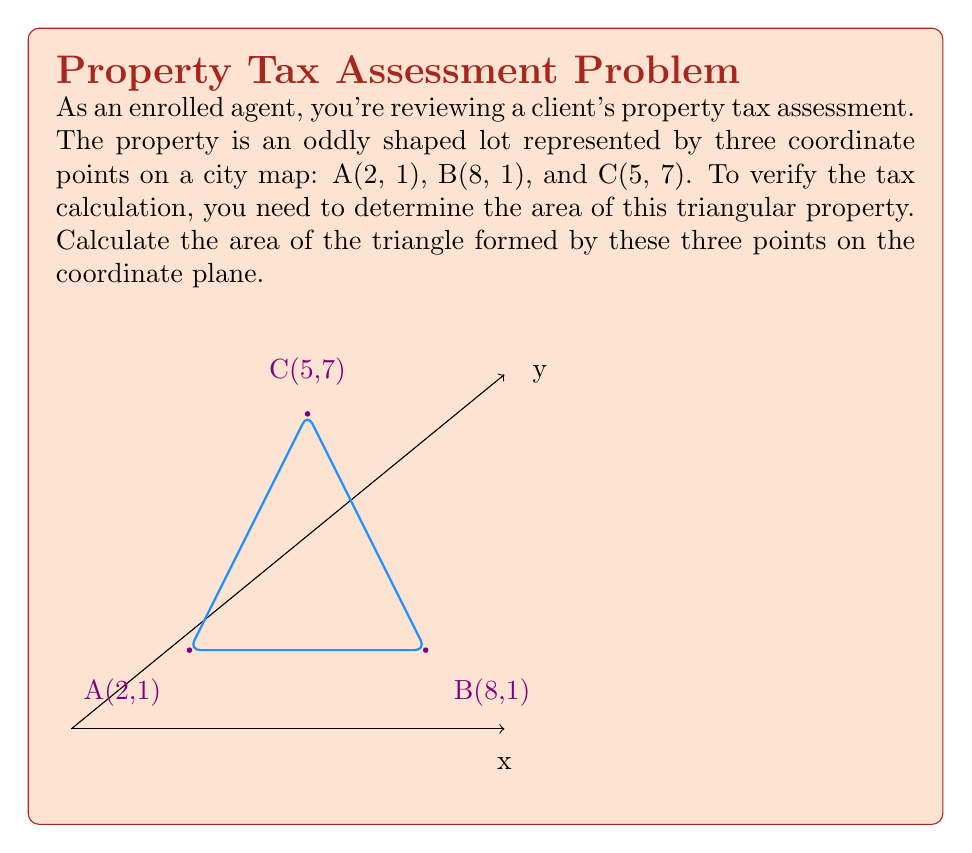Give your solution to this math problem. To calculate the area of a triangle given three points on a coordinate plane, we can use the formula:

$$Area = \frac{1}{2}|x_1(y_2 - y_3) + x_2(y_3 - y_1) + x_3(y_1 - y_2)|$$

Where $(x_1, y_1)$, $(x_2, y_2)$, and $(x_3, y_3)$ are the coordinates of the three points.

Let's follow these steps:

1) Identify the coordinates:
   A$(x_1, y_1) = (2, 1)$
   B$(x_2, y_2) = (8, 1)$
   C$(x_3, y_3) = (5, 7)$

2) Substitute these values into the formula:

   $$Area = \frac{1}{2}|2(1 - 7) + 8(7 - 1) + 5(1 - 1)|$$

3) Simplify the expressions inside the parentheses:

   $$Area = \frac{1}{2}|2(-6) + 8(6) + 5(0)|$$

4) Multiply:

   $$Area = \frac{1}{2}|-12 + 48 + 0|$$

5) Add inside the absolute value signs:

   $$Area = \frac{1}{2}|36|$$

6) Calculate the absolute value:

   $$Area = \frac{1}{2}(36)$$

7) Simplify:

   $$Area = 18$$

Therefore, the area of the triangular property is 18 square units.
Answer: 18 square units 